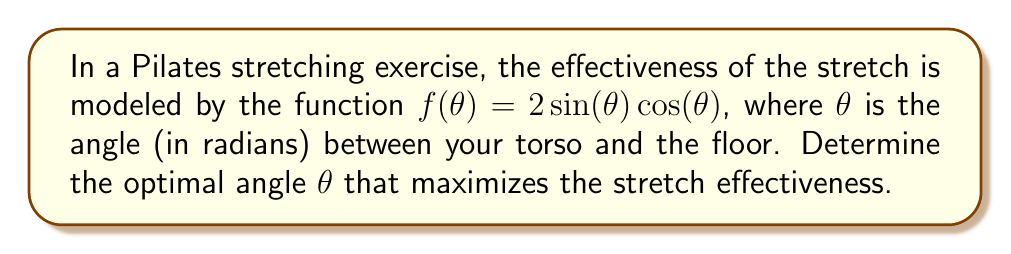Can you solve this math problem? To find the optimal angle for maximum stretch, we need to find the maximum value of the function $f(\theta) = 2\sin(\theta)\cos(\theta)$. We can do this by following these steps:

1) First, recognize that $2\sin(\theta)\cos(\theta)$ is equivalent to $\sin(2\theta)$. This is a trigonometric identity.

   $f(\theta) = 2\sin(\theta)\cos(\theta) = \sin(2\theta)$

2) To find the maximum value, we need to find where the derivative of $f(\theta)$ equals zero.

3) The derivative of $\sin(2\theta)$ is:
   
   $f'(\theta) = 2\cos(2\theta)$

4) Set the derivative equal to zero and solve:

   $2\cos(2\theta) = 0$
   $\cos(2\theta) = 0$

5) The cosine function equals zero when its argument is $\frac{\pi}{2}$ or $\frac{3\pi}{2}$. So:

   $2\theta = \frac{\pi}{2}$ or $2\theta = \frac{3\pi}{2}$

6) Solving for $\theta$:

   $\theta = \frac{\pi}{4}$ or $\theta = \frac{3\pi}{4}$

7) To determine which of these gives the maximum (rather than minimum) value, we can check the second derivative or simply evaluate $f(\theta)$ at these points:

   $f(\frac{\pi}{4}) = \sin(\frac{\pi}{2}) = 1$
   $f(\frac{3\pi}{4}) = \sin(\frac{3\pi}{2}) = -1$

8) Therefore, the maximum occurs at $\theta = \frac{\pi}{4}$.

9) Converting to degrees: $\frac{\pi}{4}$ radians = 45°
Answer: 45° 